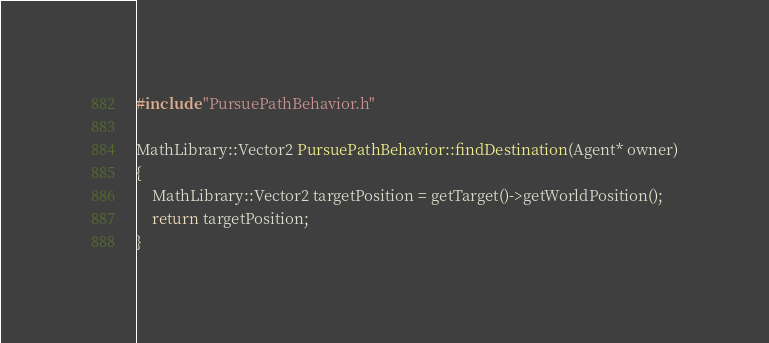<code> <loc_0><loc_0><loc_500><loc_500><_C++_>#include "PursuePathBehavior.h"

MathLibrary::Vector2 PursuePathBehavior::findDestination(Agent* owner)
{
    MathLibrary::Vector2 targetPosition = getTarget()->getWorldPosition();
    return targetPosition;
}</code> 